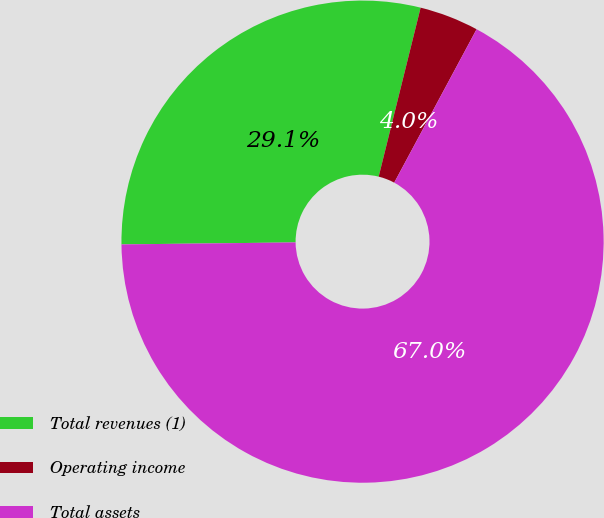Convert chart to OTSL. <chart><loc_0><loc_0><loc_500><loc_500><pie_chart><fcel>Total revenues (1)<fcel>Operating income<fcel>Total assets<nl><fcel>29.06%<fcel>3.97%<fcel>66.98%<nl></chart> 